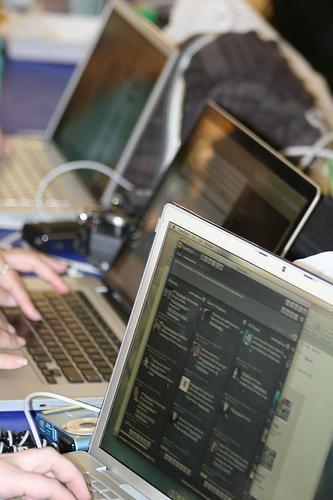How many hands are visible?
Give a very brief answer. 3. How many computers are there?
Give a very brief answer. 3. How many people can you see?
Give a very brief answer. 2. How many laptops can you see?
Give a very brief answer. 3. How many keyboards can you see?
Give a very brief answer. 2. How many horses are grazing on the hill?
Give a very brief answer. 0. 